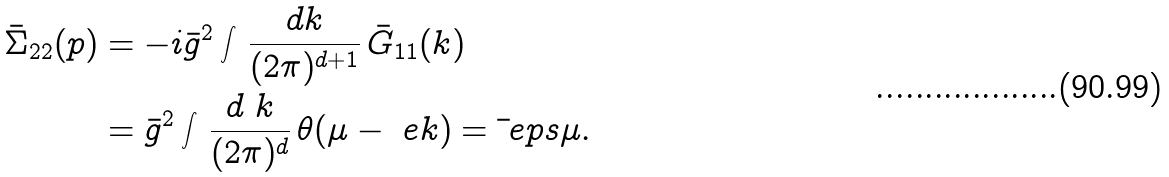Convert formula to latex. <formula><loc_0><loc_0><loc_500><loc_500>\bar { \Sigma } _ { 2 2 } ( p ) & = - i \bar { g } ^ { 2 } \int \, \frac { d k } { ( 2 \pi ) ^ { d + 1 } } \, \bar { G } _ { 1 1 } ( k ) \\ & = \bar { g } ^ { 2 } \int \, \frac { d \ k } { ( 2 \pi ) ^ { d } } \, \theta ( \mu - \ e k ) = \bar { \ } e p s \mu .</formula> 